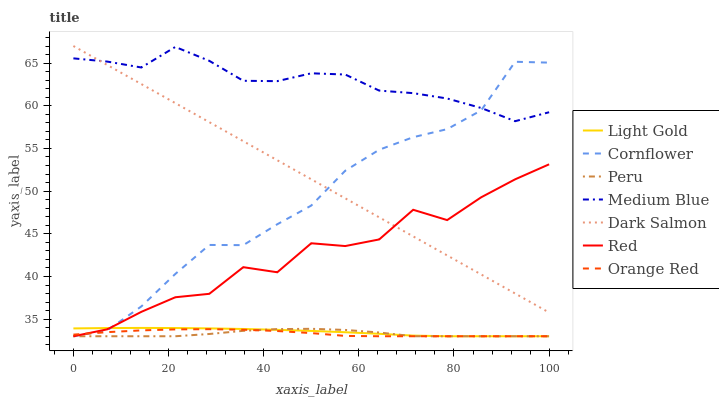Does Peru have the minimum area under the curve?
Answer yes or no. Yes. Does Medium Blue have the maximum area under the curve?
Answer yes or no. Yes. Does Dark Salmon have the minimum area under the curve?
Answer yes or no. No. Does Dark Salmon have the maximum area under the curve?
Answer yes or no. No. Is Dark Salmon the smoothest?
Answer yes or no. Yes. Is Red the roughest?
Answer yes or no. Yes. Is Medium Blue the smoothest?
Answer yes or no. No. Is Medium Blue the roughest?
Answer yes or no. No. Does Cornflower have the lowest value?
Answer yes or no. Yes. Does Dark Salmon have the lowest value?
Answer yes or no. No. Does Dark Salmon have the highest value?
Answer yes or no. Yes. Does Medium Blue have the highest value?
Answer yes or no. No. Is Peru less than Medium Blue?
Answer yes or no. Yes. Is Medium Blue greater than Light Gold?
Answer yes or no. Yes. Does Dark Salmon intersect Medium Blue?
Answer yes or no. Yes. Is Dark Salmon less than Medium Blue?
Answer yes or no. No. Is Dark Salmon greater than Medium Blue?
Answer yes or no. No. Does Peru intersect Medium Blue?
Answer yes or no. No. 